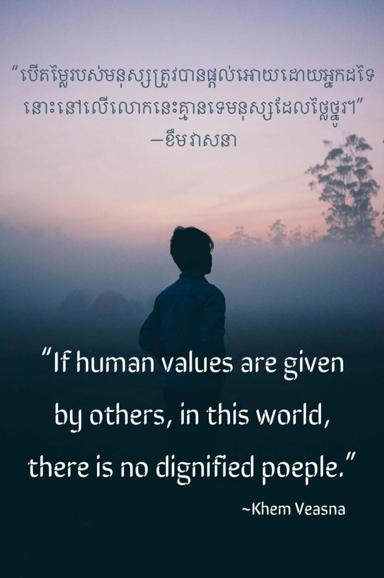Can you suggest how the sentiment expressed in this quote might impact personal growth? The sentiment expressed by Khem Veasna highlights that personal growth is deeply interconnected with the authenticity of one's values. When individuals forge their own beliefs, they develop resilience, a clearer sense of self, and an empowered approach to life's challenges, as opposed to merely conforming to external standards which might not resonate with their true selves. 